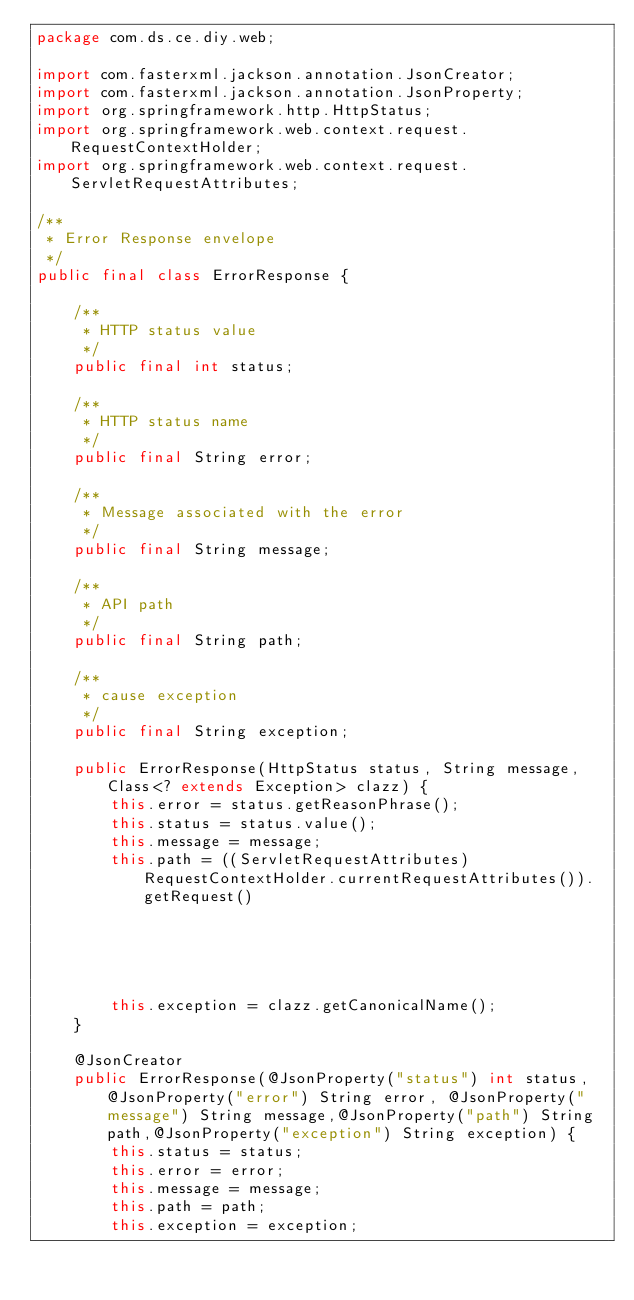Convert code to text. <code><loc_0><loc_0><loc_500><loc_500><_Java_>package com.ds.ce.diy.web;

import com.fasterxml.jackson.annotation.JsonCreator;
import com.fasterxml.jackson.annotation.JsonProperty;
import org.springframework.http.HttpStatus;
import org.springframework.web.context.request.RequestContextHolder;
import org.springframework.web.context.request.ServletRequestAttributes;

/**
 * Error Response envelope
 */
public final class ErrorResponse {

    /**
     * HTTP status value
     */
    public final int status;

    /**
     * HTTP status name
     */
    public final String error;

    /**
     * Message associated with the error
     */
    public final String message;

    /**
     * API path
     */
    public final String path;

    /**
     * cause exception
     */
    public final String exception;

    public ErrorResponse(HttpStatus status, String message, Class<? extends Exception> clazz) {
        this.error = status.getReasonPhrase();
        this.status = status.value();
        this.message = message;
        this.path = ((ServletRequestAttributes) RequestContextHolder.currentRequestAttributes()).getRequest()
                                                                                                .getServletPath();
        this.exception = clazz.getCanonicalName();
    }

    @JsonCreator
    public ErrorResponse(@JsonProperty("status") int status, @JsonProperty("error") String error, @JsonProperty("message") String message,@JsonProperty("path") String path,@JsonProperty("exception") String exception) {
        this.status = status;
        this.error = error;
        this.message = message;
        this.path = path;
        this.exception = exception;</code> 